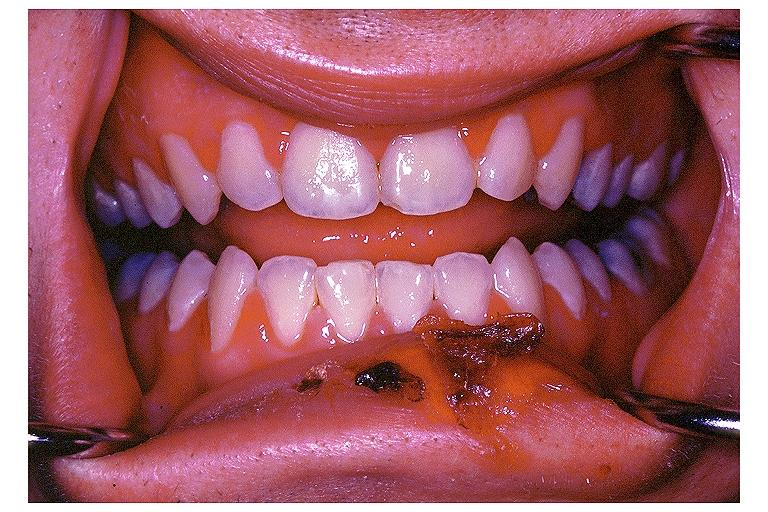where is this?
Answer the question using a single word or phrase. Oral 